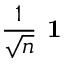<formula> <loc_0><loc_0><loc_500><loc_500>\frac { 1 } { \sqrt { n } } 1</formula> 